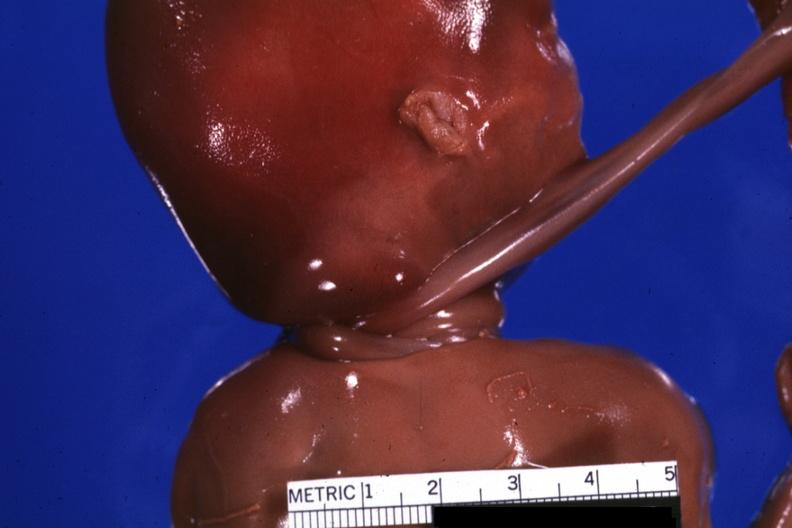s acute lymphocytic leukemia present?
Answer the question using a single word or phrase. No 